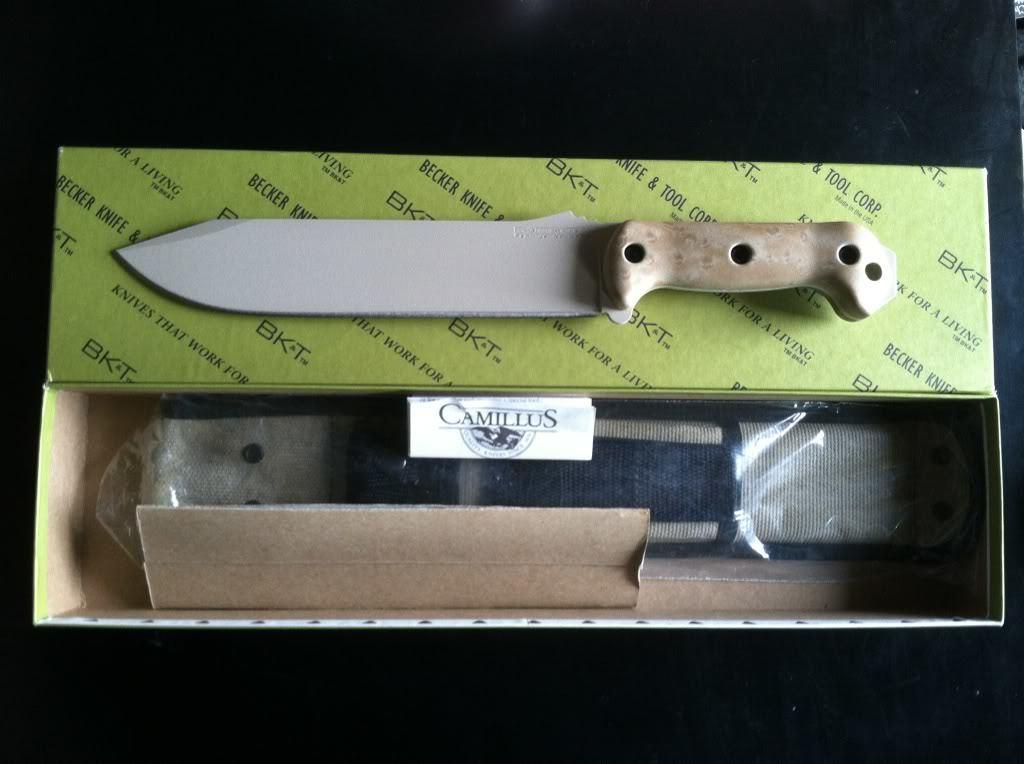What type of utensil can be seen in the image? There is a knife in the image. What is the color of the object in the image? The object in the image has ash and blue colors. Where are the objects located in the image? The objects are in a box. What color is the background of the image? The background of the image is black. What type of whip is being used to control the current in the image? There is no whip or current present in the image. How is the distribution of the objects in the box being managed in the image? The image does not show any distribution of objects in the box; it only shows the objects inside the box. 